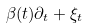<formula> <loc_0><loc_0><loc_500><loc_500>\beta ( t ) \partial _ { t } + \xi _ { t }</formula> 